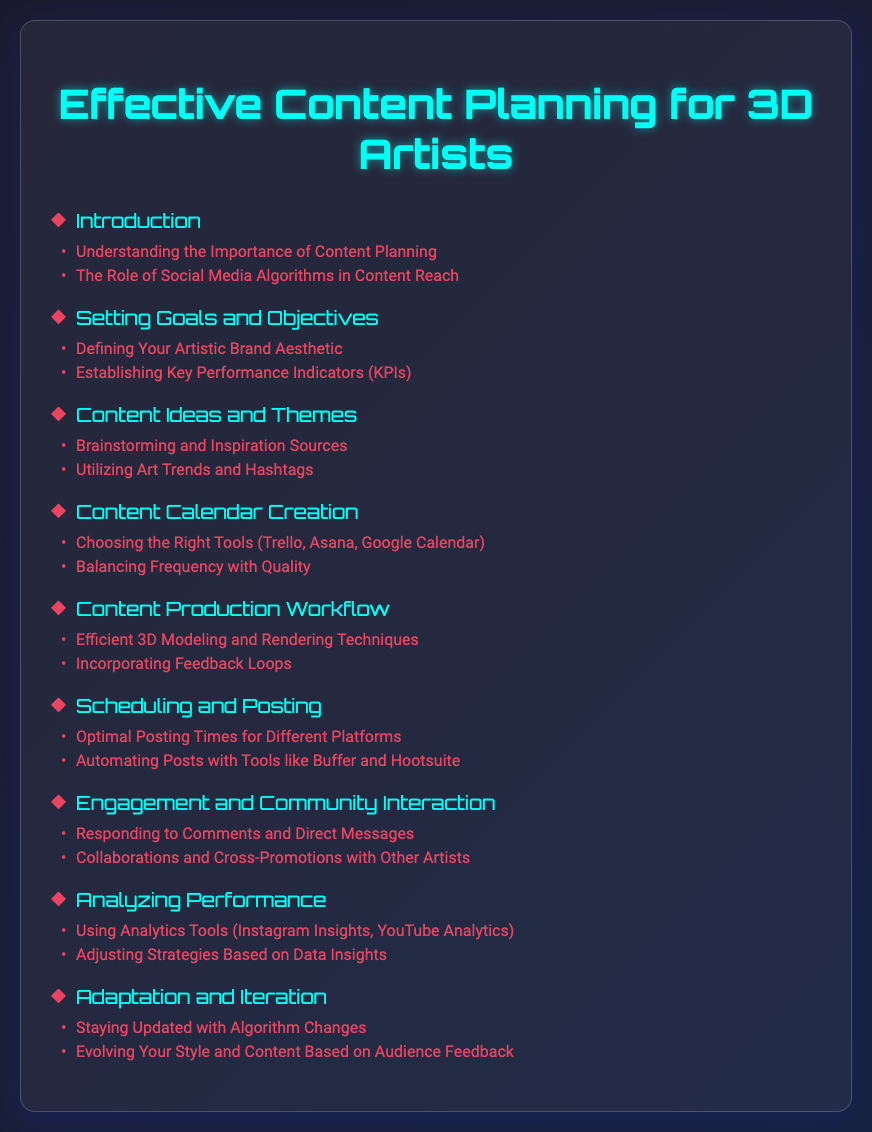What is the title of the document? The title of the document is stated at the top of the rendered HTML content and summarizes the main focus of the content.
Answer: Effective Content Planning for 3D Artists What is the first section in the Table of Contents? The first section listed in the Table of Contents introduces the topic and is essential for understanding the context of the document.
Answer: Introduction How many subsections are under 'Content Ideas and Themes'? This refers to the number of detailed parts included beneath the main section, indicating the depth of content covered.
Answer: 2 Which tool is suggested for creating a content calendar? This question pertains to the specific tools recommended for a process explained in the document, relevant for 3D artists.
Answer: Trello What is one method mentioned under 'Engagement and Community Interaction'? This seeks to identify a particular strategy recommended for fostering interaction with the audience, which is vital for maintaining a following.
Answer: Collaborations and Cross-Promotions with Other Artists How many total sections are in the Table of Contents? This question counts the main sections listed to understand the document's structure and comprehensive coverage of the topic.
Answer: 8 What does the section 'Analyzing Performance' focus on? This is aimed at uncovering the main theme or aspect discussed in this section of the document, relevant for assessing social media strategy effectiveness.
Answer: Using Analytics Tools Which social media platform's insights are mentioned? This looks for the specific platform highlighted in the analysis section, providing examples of tools for performance measurement.
Answer: Instagram Insights 